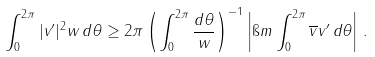Convert formula to latex. <formula><loc_0><loc_0><loc_500><loc_500>\int _ { 0 } ^ { 2 \pi } | v ^ { \prime } | ^ { 2 } w \, d \theta \geq 2 \pi \left ( \int _ { 0 } ^ { 2 \pi } \frac { d \theta } { w } \right ) ^ { - 1 } \left | \i m \int _ { 0 } ^ { 2 \pi } \overline { v } v ^ { \prime } \, d \theta \right | \, .</formula> 